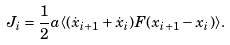<formula> <loc_0><loc_0><loc_500><loc_500>J _ { i } = \frac { 1 } { 2 } a \langle ( \dot { x } _ { i + 1 } + \dot { x } _ { i } ) F ( x _ { i + 1 } - x _ { i } ) \rangle .</formula> 